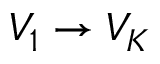Convert formula to latex. <formula><loc_0><loc_0><loc_500><loc_500>V _ { 1 } \to V _ { K }</formula> 